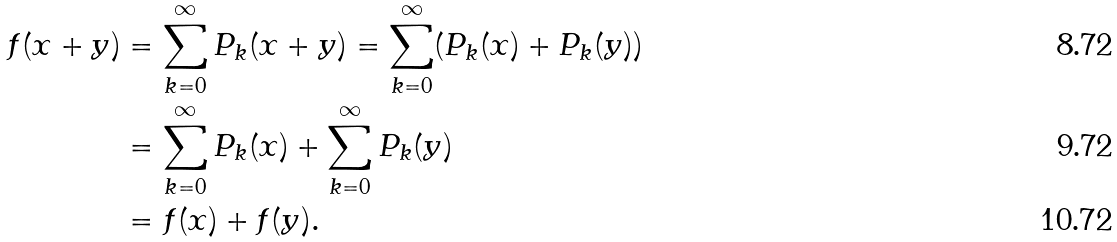<formula> <loc_0><loc_0><loc_500><loc_500>f ( x + y ) & = \sum _ { k = 0 } ^ { \infty } P _ { k } ( x + y ) = \sum _ { k = 0 } ^ { \infty } ( P _ { k } ( x ) + P _ { k } ( y ) ) \\ & = \sum _ { k = 0 } ^ { \infty } P _ { k } ( x ) + \sum _ { k = 0 } ^ { \infty } P _ { k } ( y ) \\ & = f ( x ) + f ( y ) .</formula> 